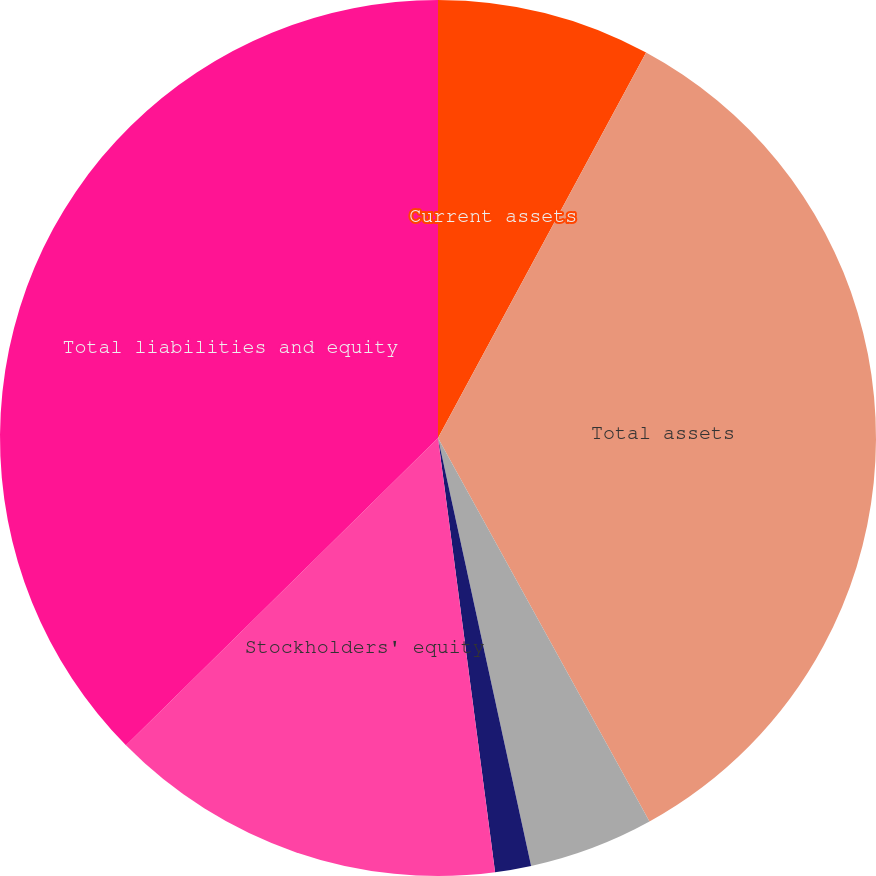<chart> <loc_0><loc_0><loc_500><loc_500><pie_chart><fcel>Current assets<fcel>Total assets<fcel>Current liabilities<fcel>Other liabilities<fcel>Stockholders' equity<fcel>Total liabilities and equity<nl><fcel>7.88%<fcel>34.1%<fcel>4.61%<fcel>1.33%<fcel>14.7%<fcel>37.38%<nl></chart> 